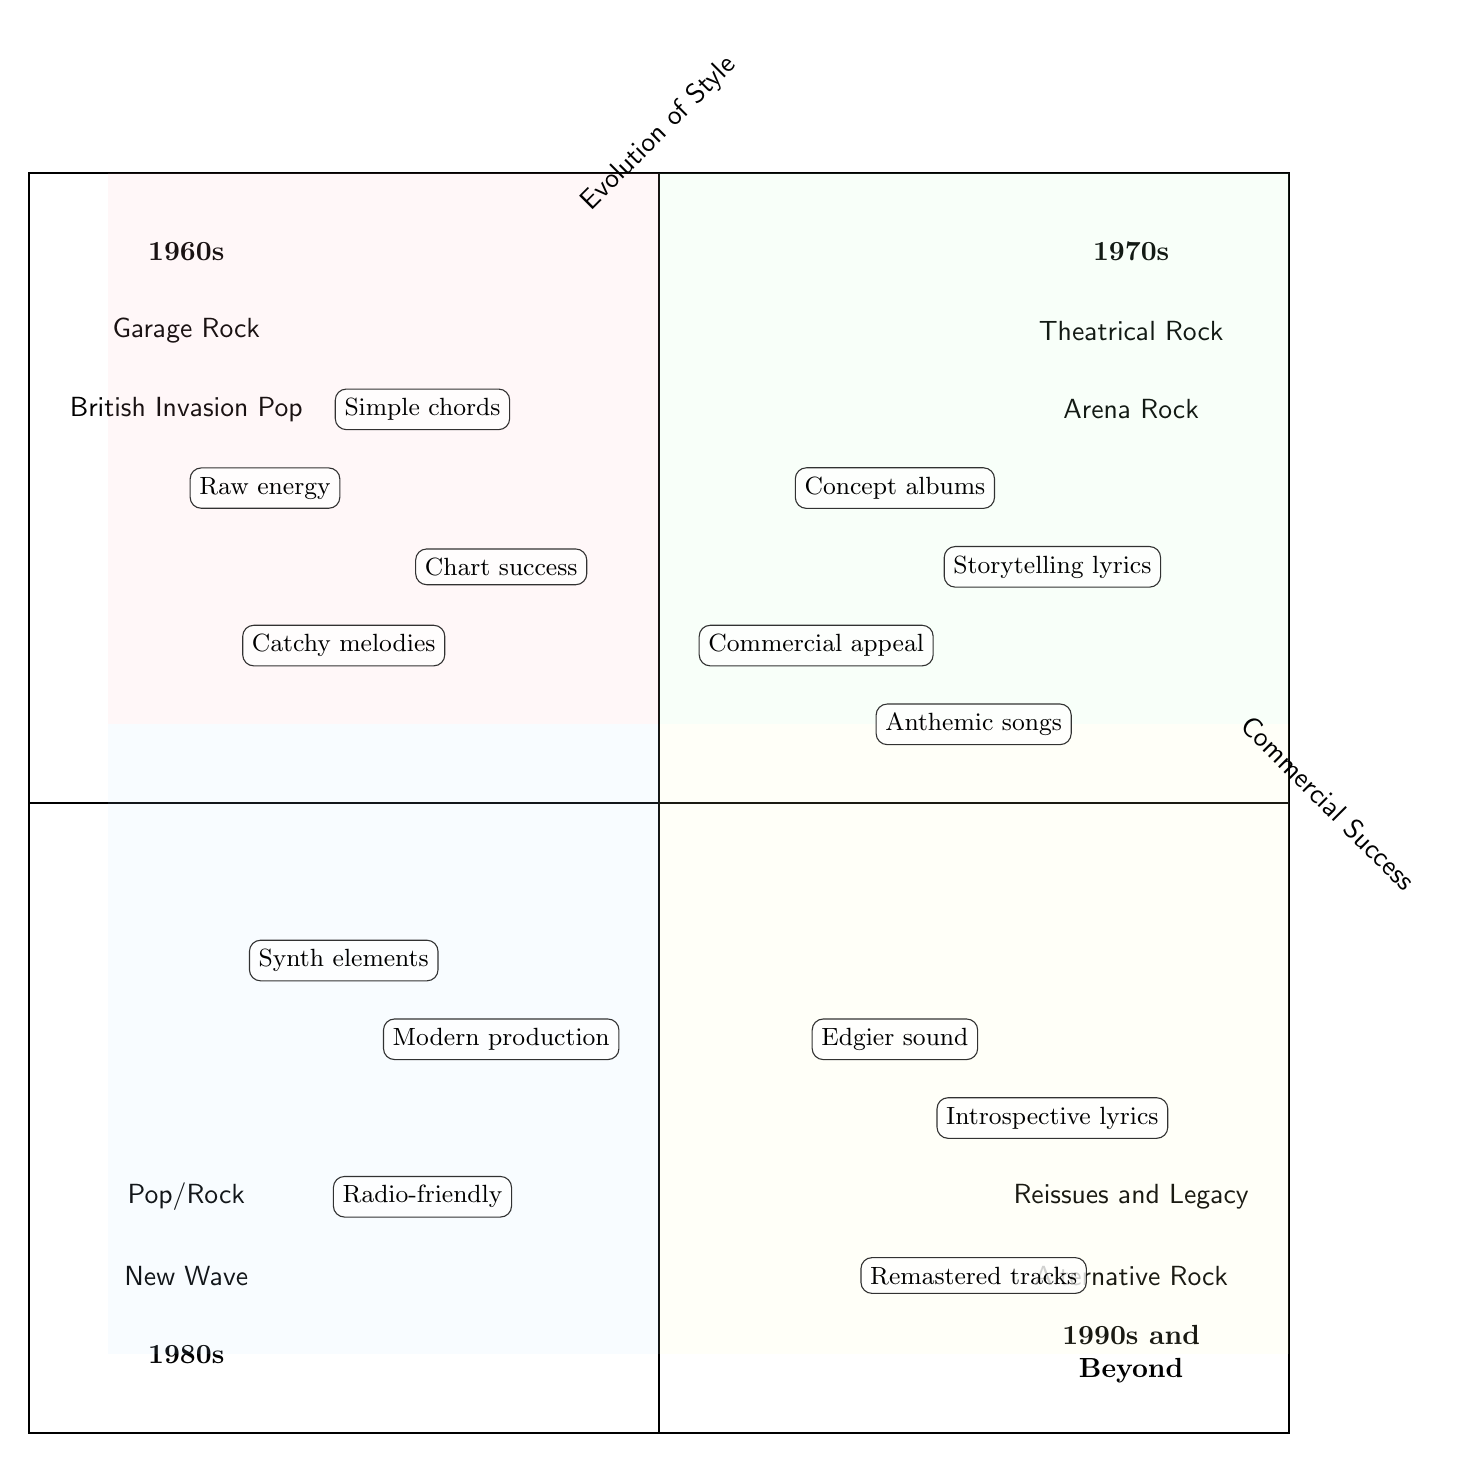What styles are present in the 1960s quadrant? In the 1960s quadrant, there are two styles listed: Garage Rock and British Invasion Pop. These can be clearly identified in the quadrant as they are listed under the decade label.
Answer: Garage Rock, British Invasion Pop Which decade features Theatrical Rock? Theatrical Rock is found in the 1970s quadrant, which is indicated by the label and the listed style beneath it.
Answer: 1970s How many music styles does the 1980s have listed? In the 1980s quadrant, there are two distinct music styles shown: New Wave and Pop/Rock. Counting these styles gives the total number.
Answer: 2 What characteristic is associated with the 1970s Arena Rock? The characteristic associated with Arena Rock in the 1970s quadrant is "Anthemic songs." This is identified alongside the Arena Rock label in the quadrant.
Answer: Anthemic songs Which two styles from the 1990s and beyond feature "Introspective lyrics"? Introspective lyrics are linked to the 1990s and beyond style of Alternative Rock, as indicated in its quadrant. The Reissues and Legacy Projects do not have that characteristic, making the answer clear.
Answer: Alternative Rock How does the evolution of music styles change from the 1960s to the 1980s according to the chart? The chart shows a transition from Garage Rock and British Invasion Pop in the 1960s, which focuses on raw energy and catchy melodies, to styles in the 1980s that emphasize more modern production elements seen in New Wave and Pop/Rock, suggesting a shift to more polished sounds and mainstream accessibility.
Answer: More polished sounds What is the relationship between the 1970s and 1990s music styles in terms of their characteristics? The 1970s styles focus on storytelling and theatrical concepts, while the 1990s styles pivot to an edgier sound and introspective themes, indicating a contrast in thematic exploration from narrative-driven content to personal and experimental music.
Answer: Contrast in thematic exploration Which musical characteristic from the 1960s relates to commercial success? The characteristic that relates to commercial success from the 1960s styles is "Chart success," which is specifically linked to the British Invasion Pop style noted in that quadrant.
Answer: Chart success 